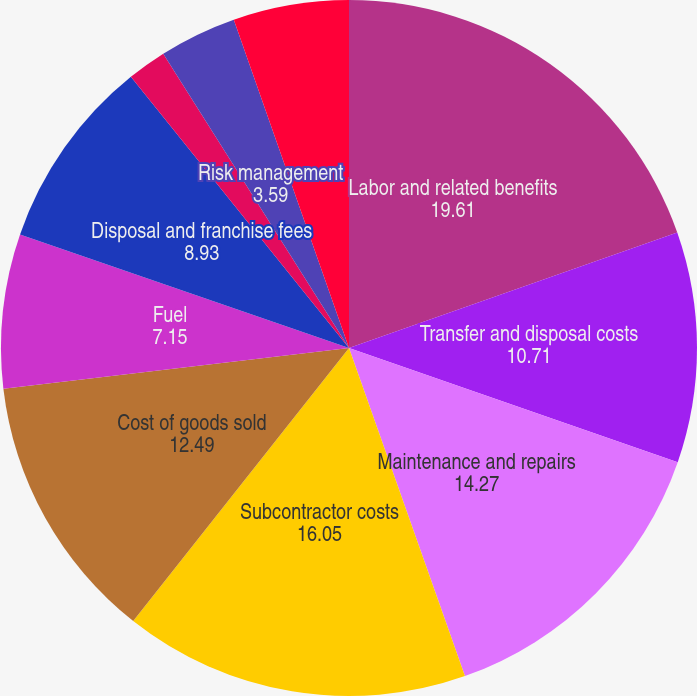Convert chart to OTSL. <chart><loc_0><loc_0><loc_500><loc_500><pie_chart><fcel>Labor and related benefits<fcel>Transfer and disposal costs<fcel>Maintenance and repairs<fcel>Subcontractor costs<fcel>Cost of goods sold<fcel>Fuel<fcel>Disposal and franchise fees<fcel>Landfill operating costs<fcel>Risk management<fcel>Other<nl><fcel>19.61%<fcel>10.71%<fcel>14.27%<fcel>16.05%<fcel>12.49%<fcel>7.15%<fcel>8.93%<fcel>1.82%<fcel>3.59%<fcel>5.37%<nl></chart> 